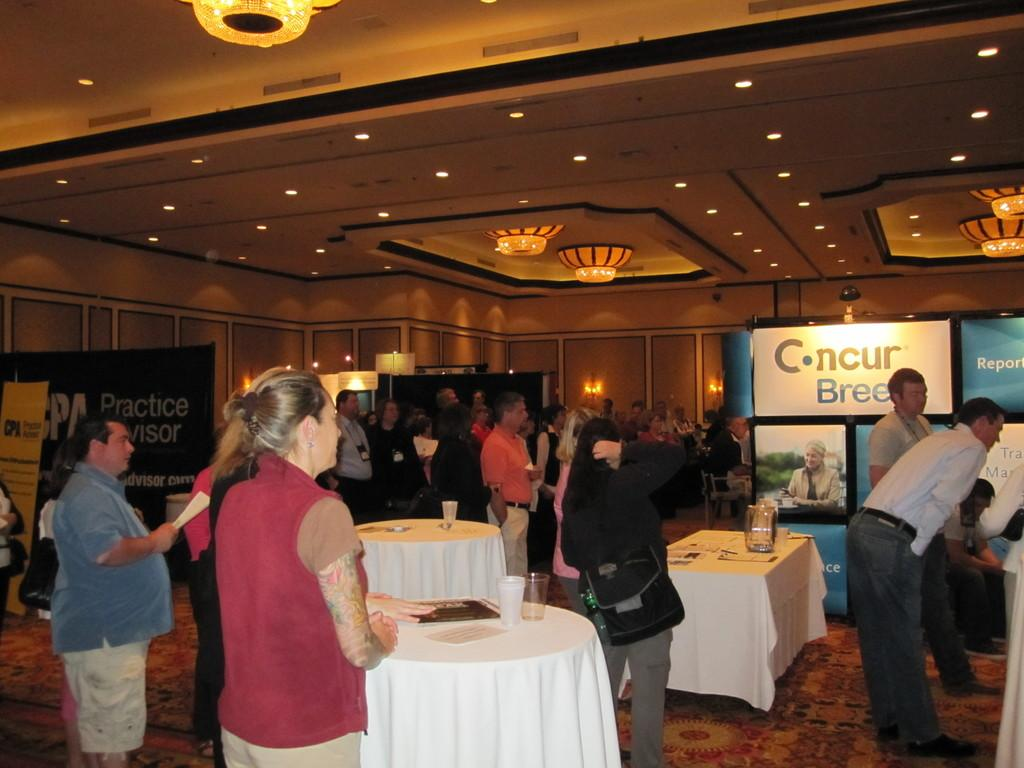How many people are in the image? There is a group of people in the image, but the exact number is not specified. What are the people in the image doing? The people are standing in the image. What can be seen on the tables in the image? Glasses are present on the tables in the image. What type of lighting is visible in the image? There are chandelier lights in the image. What type of jeans is the person wearing in the image? There is no information about anyone wearing jeans in the image. What game are the people playing in the image? There is no game being played in the image; the people are simply standing. 